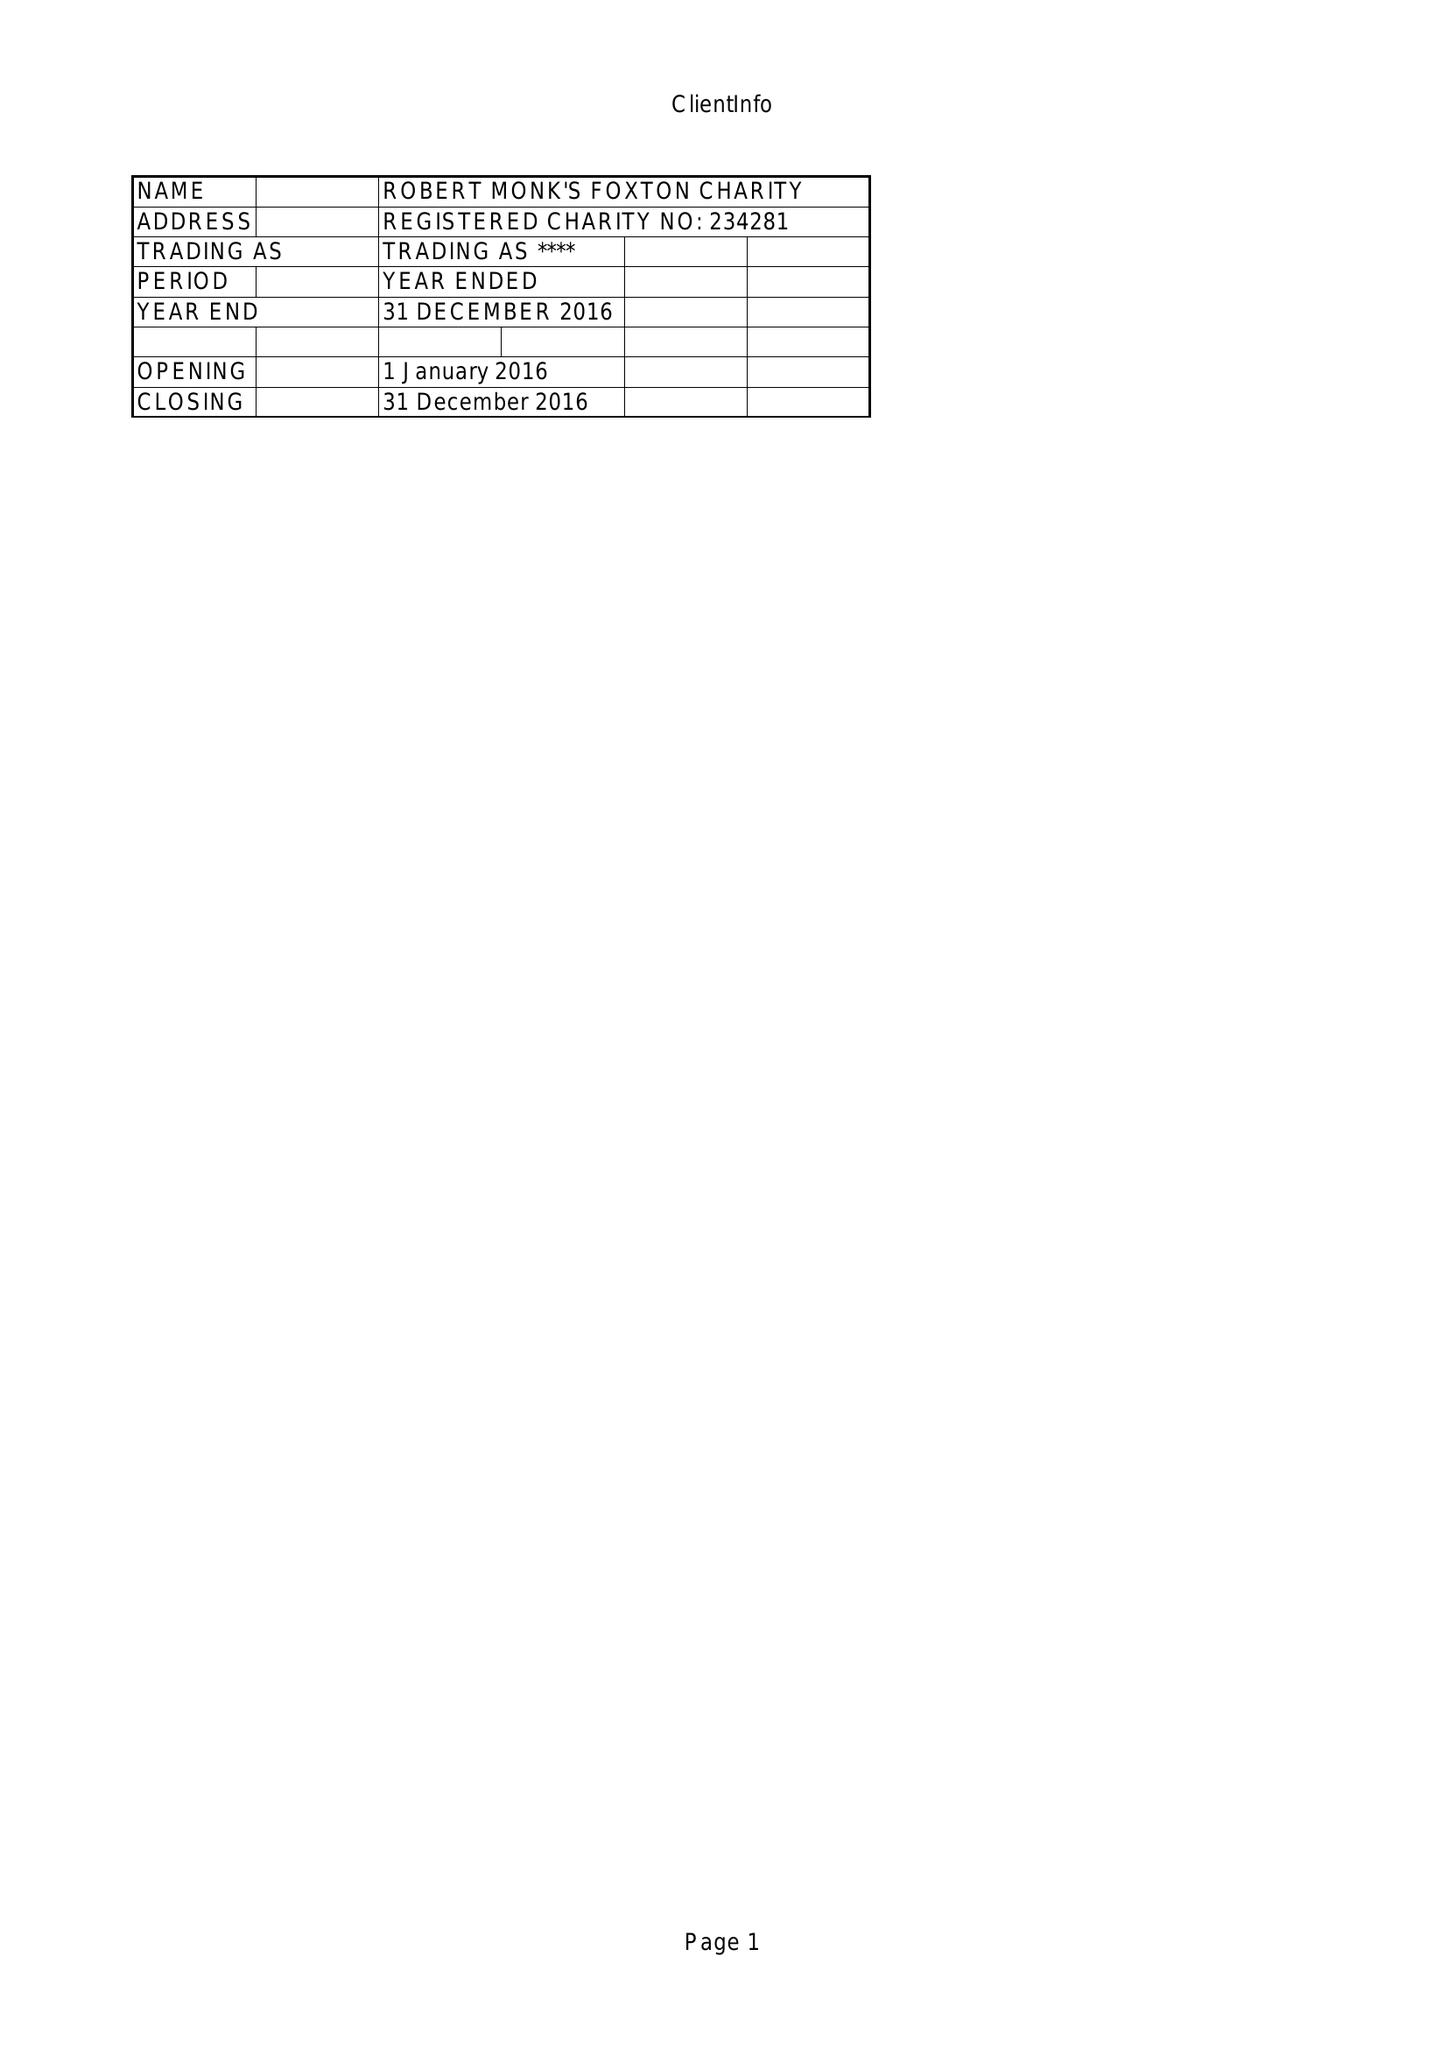What is the value for the address__postcode?
Answer the question using a single word or phrase. LE16 7RE 